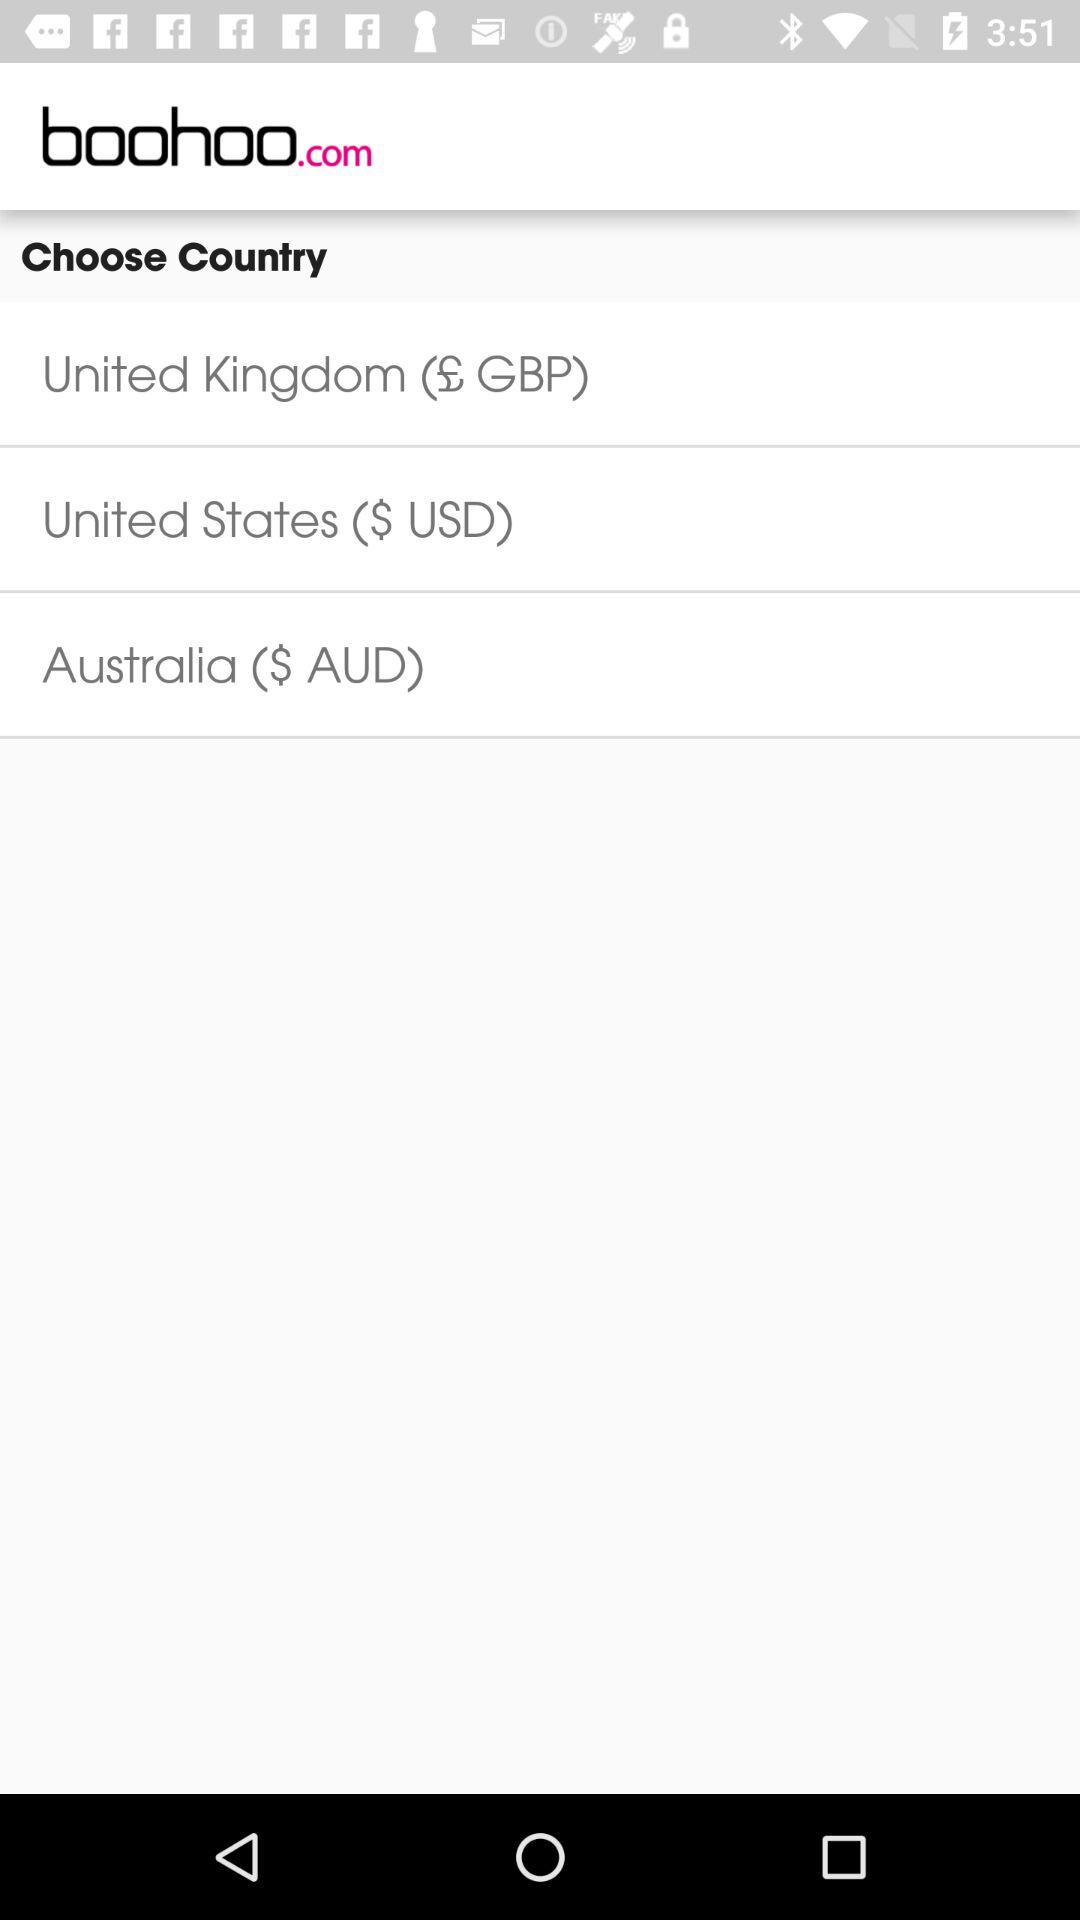What is the official currency of the United Kingdom? The official currency of the United Kingdom is GBP. 